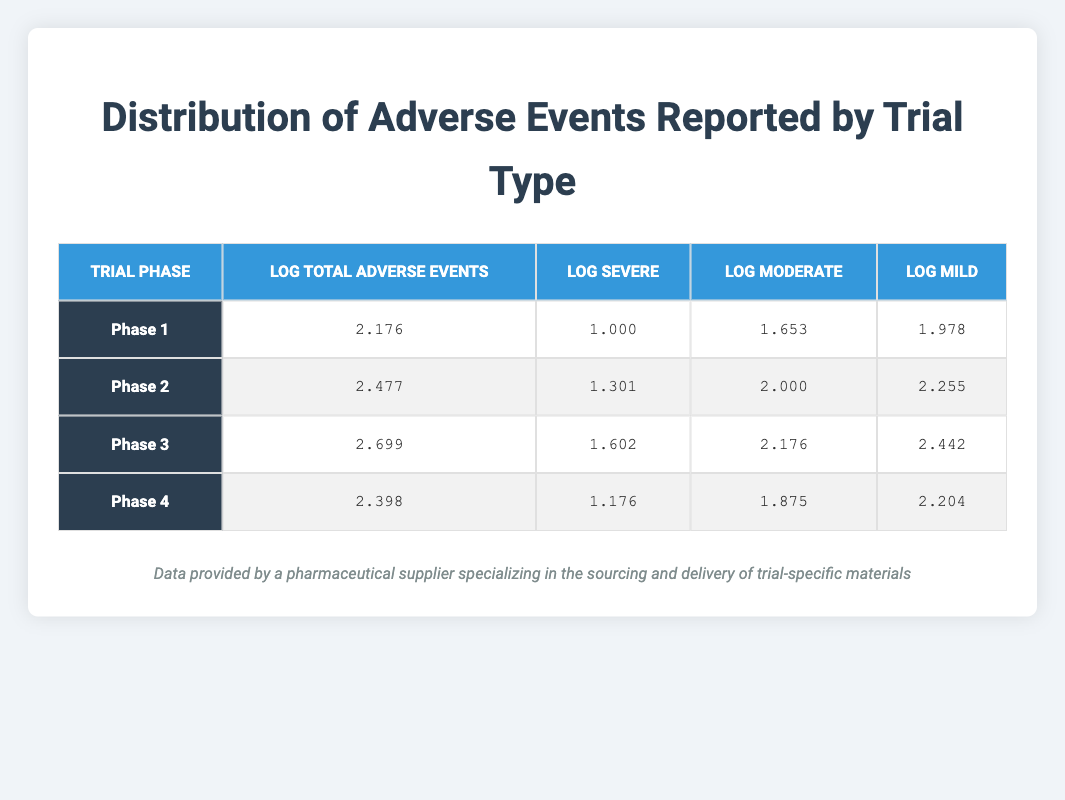What is the total number of adverse events reported in Phase 2? According to the table, the value for Total Adverse Events Reported in Phase 2 is clearly listed as 300.
Answer: 300 What is the log value for Mild adverse events in Phase 3? The log value for Mild adverse events in Phase 3 is provided in the table as 2.442.
Answer: 2.442 Which trial phase has the highest number of Severe adverse events reported? By looking at the table, Phase 3 has the highest value for Severe adverse events, which is 40.
Answer: Phase 3 What is the difference in log values for Total Adverse Events between Phase 1 and Phase 4? The log value for Phase 1 is 2.176 and for Phase 4 it is 2.398. The difference is calculated as 2.398 - 2.176 = 0.222.
Answer: 0.222 Does Phase 2 have a higher log value for Moderate adverse events than Phase 3? The log value for Moderate adverse events in Phase 2 is 2.000 while in Phase 3 it is 2.176. Since 2.000 is less than 2.176, the answer is no.
Answer: No What is the average log value for Mild adverse events across all phases? The log values for Mild adverse events are: Phase 1 - 1.978, Phase 2 - 2.255, Phase 3 - 2.442, and Phase 4 - 2.204. Summing them gives 1.978 + 2.255 + 2.442 + 2.204 = 8.879. Dividing by 4 gives an average of 8.879 / 4 = 2.21975, which can be rounded to 2.22.
Answer: 2.22 In which phase is the log value for Severe adverse events the lowest? The log values for Severe adverse events are: Phase 1 - 1.000, Phase 2 - 1.301, Phase 3 - 1.602, Phase 4 - 1.176. 1.000, being the smallest, indicates that Phase 1 has the lowest log value.
Answer: Phase 1 What is the total number of Severe adverse events reported across all phases? The total number of Severe adverse events across all phases is the sum of the values: Phase 1 - 10, Phase 2 - 20, Phase 3 - 40, Phase 4 - 15. Adding these gives 10 + 20 + 40 + 15 = 85.
Answer: 85 Is the log value for Total Adverse Events in Phase 4 greater than that in Phase 2? The log value for Phase 4 is 2.398, while for Phase 2 it is 2.477. Since 2.398 is less than 2.477, the answer is no.
Answer: No 